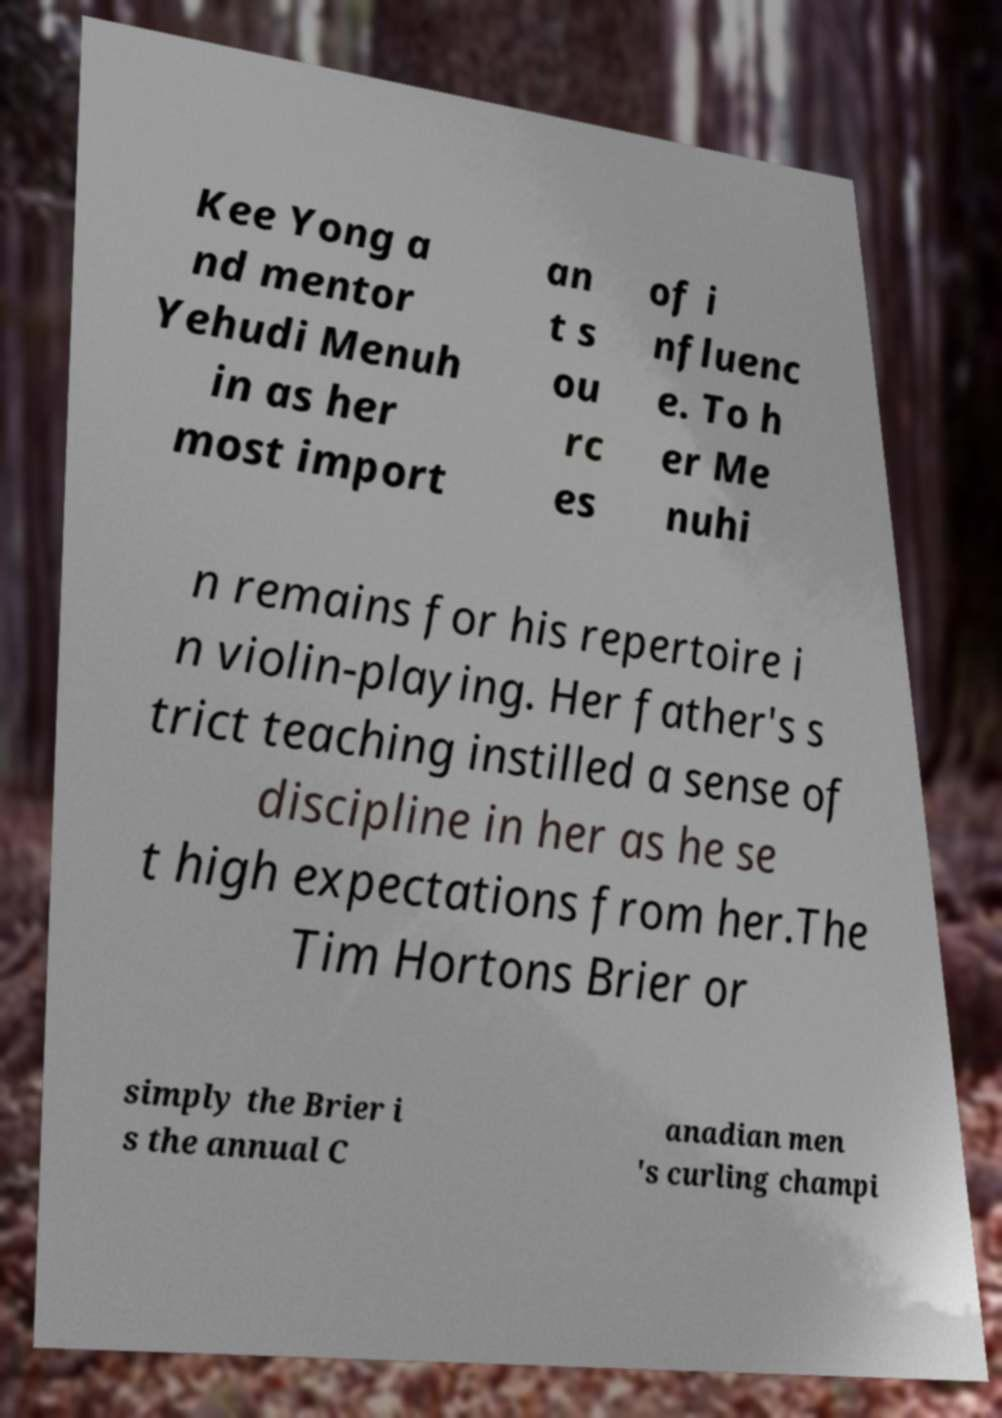Could you extract and type out the text from this image? Kee Yong a nd mentor Yehudi Menuh in as her most import an t s ou rc es of i nfluenc e. To h er Me nuhi n remains for his repertoire i n violin-playing. Her father's s trict teaching instilled a sense of discipline in her as he se t high expectations from her.The Tim Hortons Brier or simply the Brier i s the annual C anadian men 's curling champi 